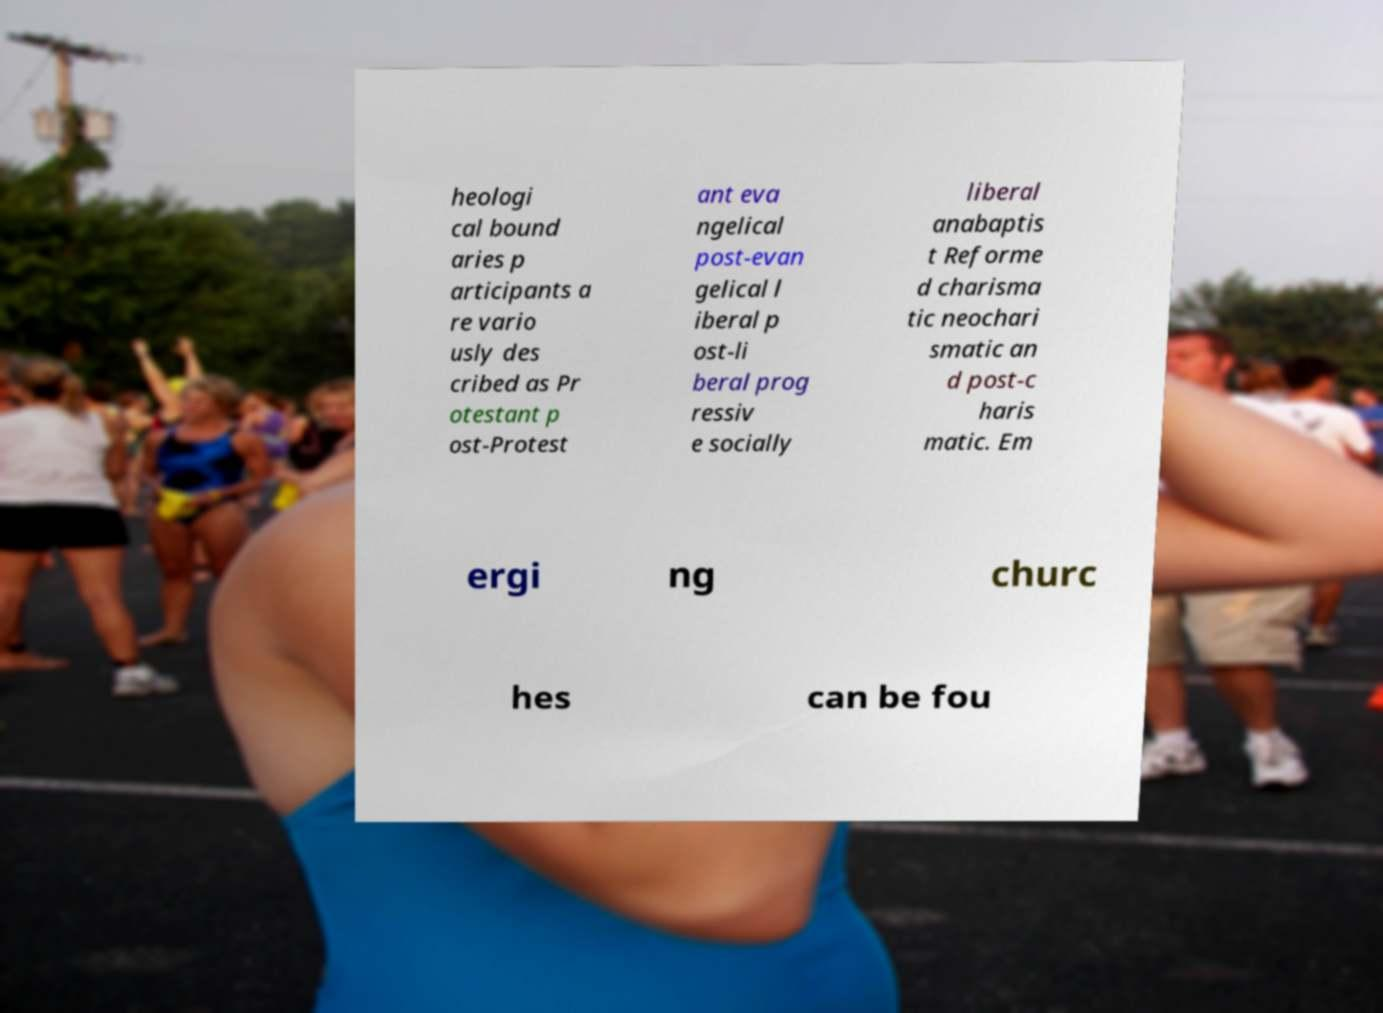I need the written content from this picture converted into text. Can you do that? heologi cal bound aries p articipants a re vario usly des cribed as Pr otestant p ost-Protest ant eva ngelical post-evan gelical l iberal p ost-li beral prog ressiv e socially liberal anabaptis t Reforme d charisma tic neochari smatic an d post-c haris matic. Em ergi ng churc hes can be fou 